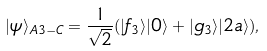<formula> <loc_0><loc_0><loc_500><loc_500>| \psi \rangle _ { A 3 - C } = \frac { 1 } { \sqrt { 2 } } ( | f _ { 3 } \rangle | 0 \rangle + | g _ { 3 } \rangle | 2 a \rangle ) ,</formula> 